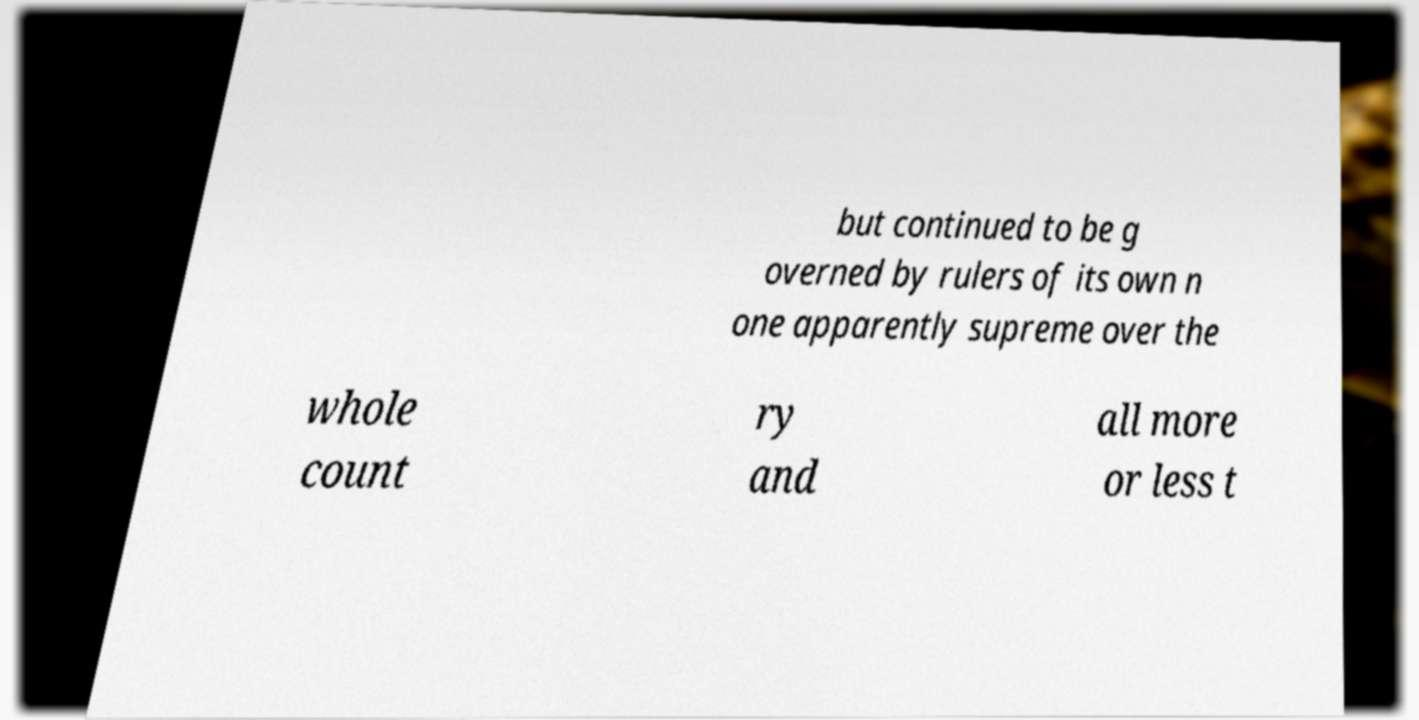Can you accurately transcribe the text from the provided image for me? but continued to be g overned by rulers of its own n one apparently supreme over the whole count ry and all more or less t 